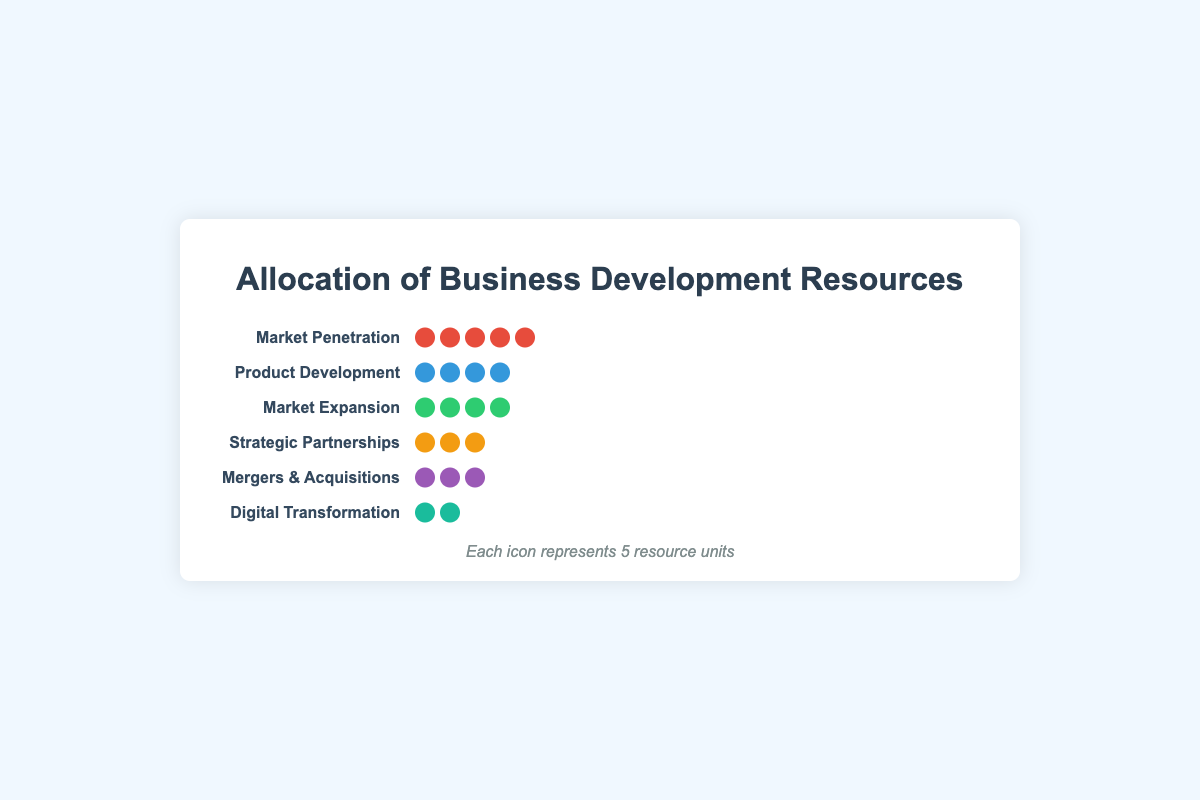Which strategy receives the most resources? The figure shows that Market Penetration has the most icons representing resource units.
Answer: Market Penetration How many total resource units are allocated to Product Development? Each icon represents 5 resource units, and there are 4 icons for Product Development. So, the total is 4 * 5 = 20 units.
Answer: 20 units What is the combined resource allocation for Market Penetration and Digital Transformation? Market Penetration has 5 icons and Digital Transformation has 2 icons. Each icon represents 5 units. So, (5 * 5) + (2 * 5) = 25 + 10 = 35 units.
Answer: 35 units Which strategy receives fewer resources: Mergers & Acquisitions or Strategic Partnerships? Mergers & Acquisitions has 3 icons while Strategic Partnerships also has 3 icons, so they receive an equal number of resources.
Answer: Equal How many more units does Market Penetration receive than Market Expansion? Market Penetration has 5 icons (5 * 5 = 25 units) and Market Expansion has 4 icons (4 * 5 = 20 units). So, Market Penetration receives 25 - 20 = 5 more units.
Answer: 5 more units What is the percentage of resources allocated to Digital Transformation compared to the total resources? The total number of units is 25 (Market Penetration) + 20 (Product Development) + 18 (Market Expansion) + 15 (Strategic Partnerships) + 12 (Mergers & Acquisitions) + 10 (Digital Transformation) = 100 units. Digital Transformation receives 10 units, so the percentage is (10 / 100) * 100 = 10%.
Answer: 10% Which strategies receive the same allocation of resources? Both Market Expansion and Product Development have 4 icons, which corresponds to 20 units each. So they receive the same allocation.
Answer: Market Expansion and Product Development How is the legend represented in the figure and what does it signify? The legend is at the bottom of the figure, explaining that each icon represents 5 units of resources.
Answer: Each icon represents 5 units What proportion of total resources is allocated to Strategic Partnerships? Strategic Partnerships has 3 icons, so it has 3 * 5 = 15 units. The total resources are 100 units. Thus, the proportion is 15 / 100 = 0.15 or 15%.
Answer: 15% How many strategies have more than 3 icons representing resource units? Market Penetration (5 icons), Product Development (4 icons), and Market Expansion (4 icons) each have more than 3 icons. Thus, there are three strategies.
Answer: Three strategies 